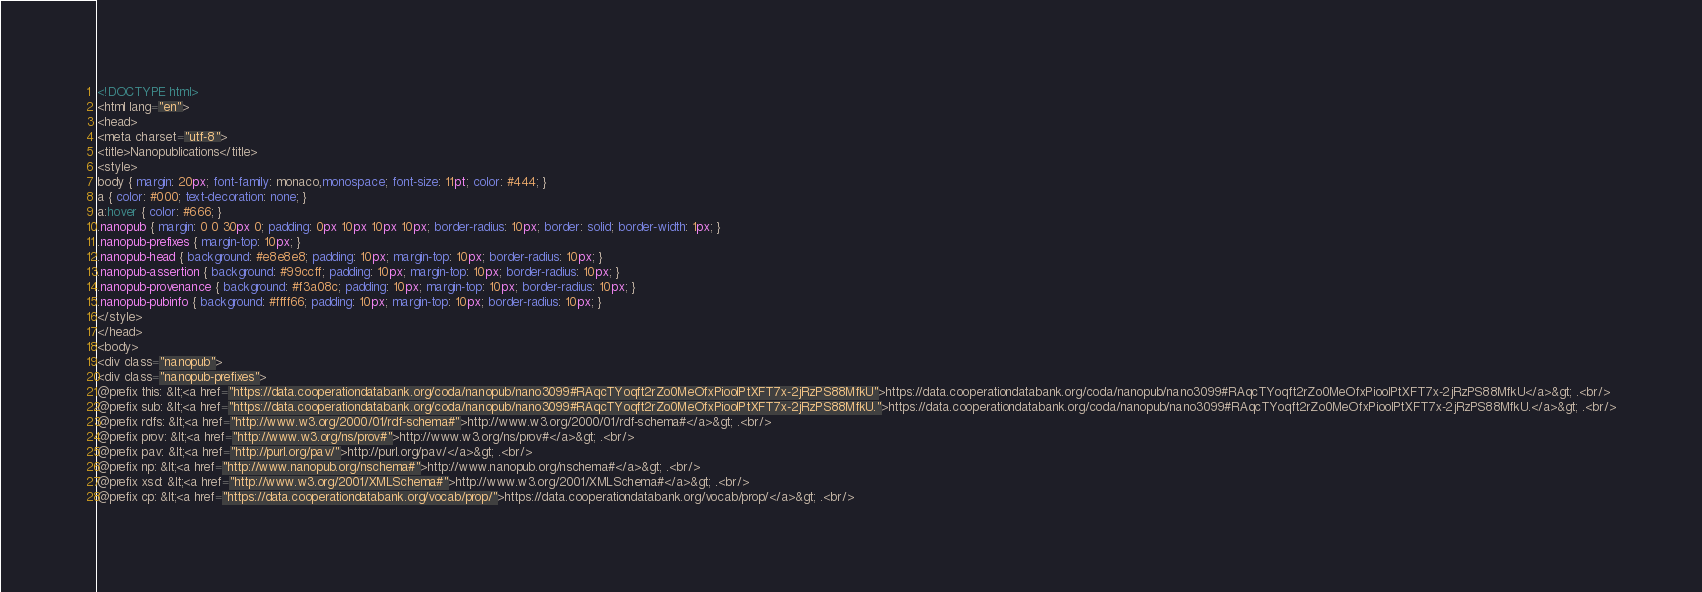Convert code to text. <code><loc_0><loc_0><loc_500><loc_500><_HTML_><!DOCTYPE html>
<html lang="en">
<head>
<meta charset="utf-8">
<title>Nanopublications</title>
<style>
body { margin: 20px; font-family: monaco,monospace; font-size: 11pt; color: #444; }
a { color: #000; text-decoration: none; }
a:hover { color: #666; }
.nanopub { margin: 0 0 30px 0; padding: 0px 10px 10px 10px; border-radius: 10px; border: solid; border-width: 1px; }
.nanopub-prefixes { margin-top: 10px; }
.nanopub-head { background: #e8e8e8; padding: 10px; margin-top: 10px; border-radius: 10px; }
.nanopub-assertion { background: #99ccff; padding: 10px; margin-top: 10px; border-radius: 10px; }
.nanopub-provenance { background: #f3a08c; padding: 10px; margin-top: 10px; border-radius: 10px; }
.nanopub-pubinfo { background: #ffff66; padding: 10px; margin-top: 10px; border-radius: 10px; }
</style>
</head>
<body>
<div class="nanopub">
<div class="nanopub-prefixes">
@prefix this: &lt;<a href="https://data.cooperationdatabank.org/coda/nanopub/nano3099#RAqcTYoqft2rZo0MeOfxPioolPtXFT7x-2jRzPS88MfkU">https://data.cooperationdatabank.org/coda/nanopub/nano3099#RAqcTYoqft2rZo0MeOfxPioolPtXFT7x-2jRzPS88MfkU</a>&gt; .<br/>
@prefix sub: &lt;<a href="https://data.cooperationdatabank.org/coda/nanopub/nano3099#RAqcTYoqft2rZo0MeOfxPioolPtXFT7x-2jRzPS88MfkU.">https://data.cooperationdatabank.org/coda/nanopub/nano3099#RAqcTYoqft2rZo0MeOfxPioolPtXFT7x-2jRzPS88MfkU.</a>&gt; .<br/>
@prefix rdfs: &lt;<a href="http://www.w3.org/2000/01/rdf-schema#">http://www.w3.org/2000/01/rdf-schema#</a>&gt; .<br/>
@prefix prov: &lt;<a href="http://www.w3.org/ns/prov#">http://www.w3.org/ns/prov#</a>&gt; .<br/>
@prefix pav: &lt;<a href="http://purl.org/pav/">http://purl.org/pav/</a>&gt; .<br/>
@prefix np: &lt;<a href="http://www.nanopub.org/nschema#">http://www.nanopub.org/nschema#</a>&gt; .<br/>
@prefix xsd: &lt;<a href="http://www.w3.org/2001/XMLSchema#">http://www.w3.org/2001/XMLSchema#</a>&gt; .<br/>
@prefix cp: &lt;<a href="https://data.cooperationdatabank.org/vocab/prop/">https://data.cooperationdatabank.org/vocab/prop/</a>&gt; .<br/></code> 